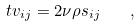<formula> <loc_0><loc_0><loc_500><loc_500>\ t v _ { i j } = 2 \nu \rho s _ { i j } \quad ,</formula> 